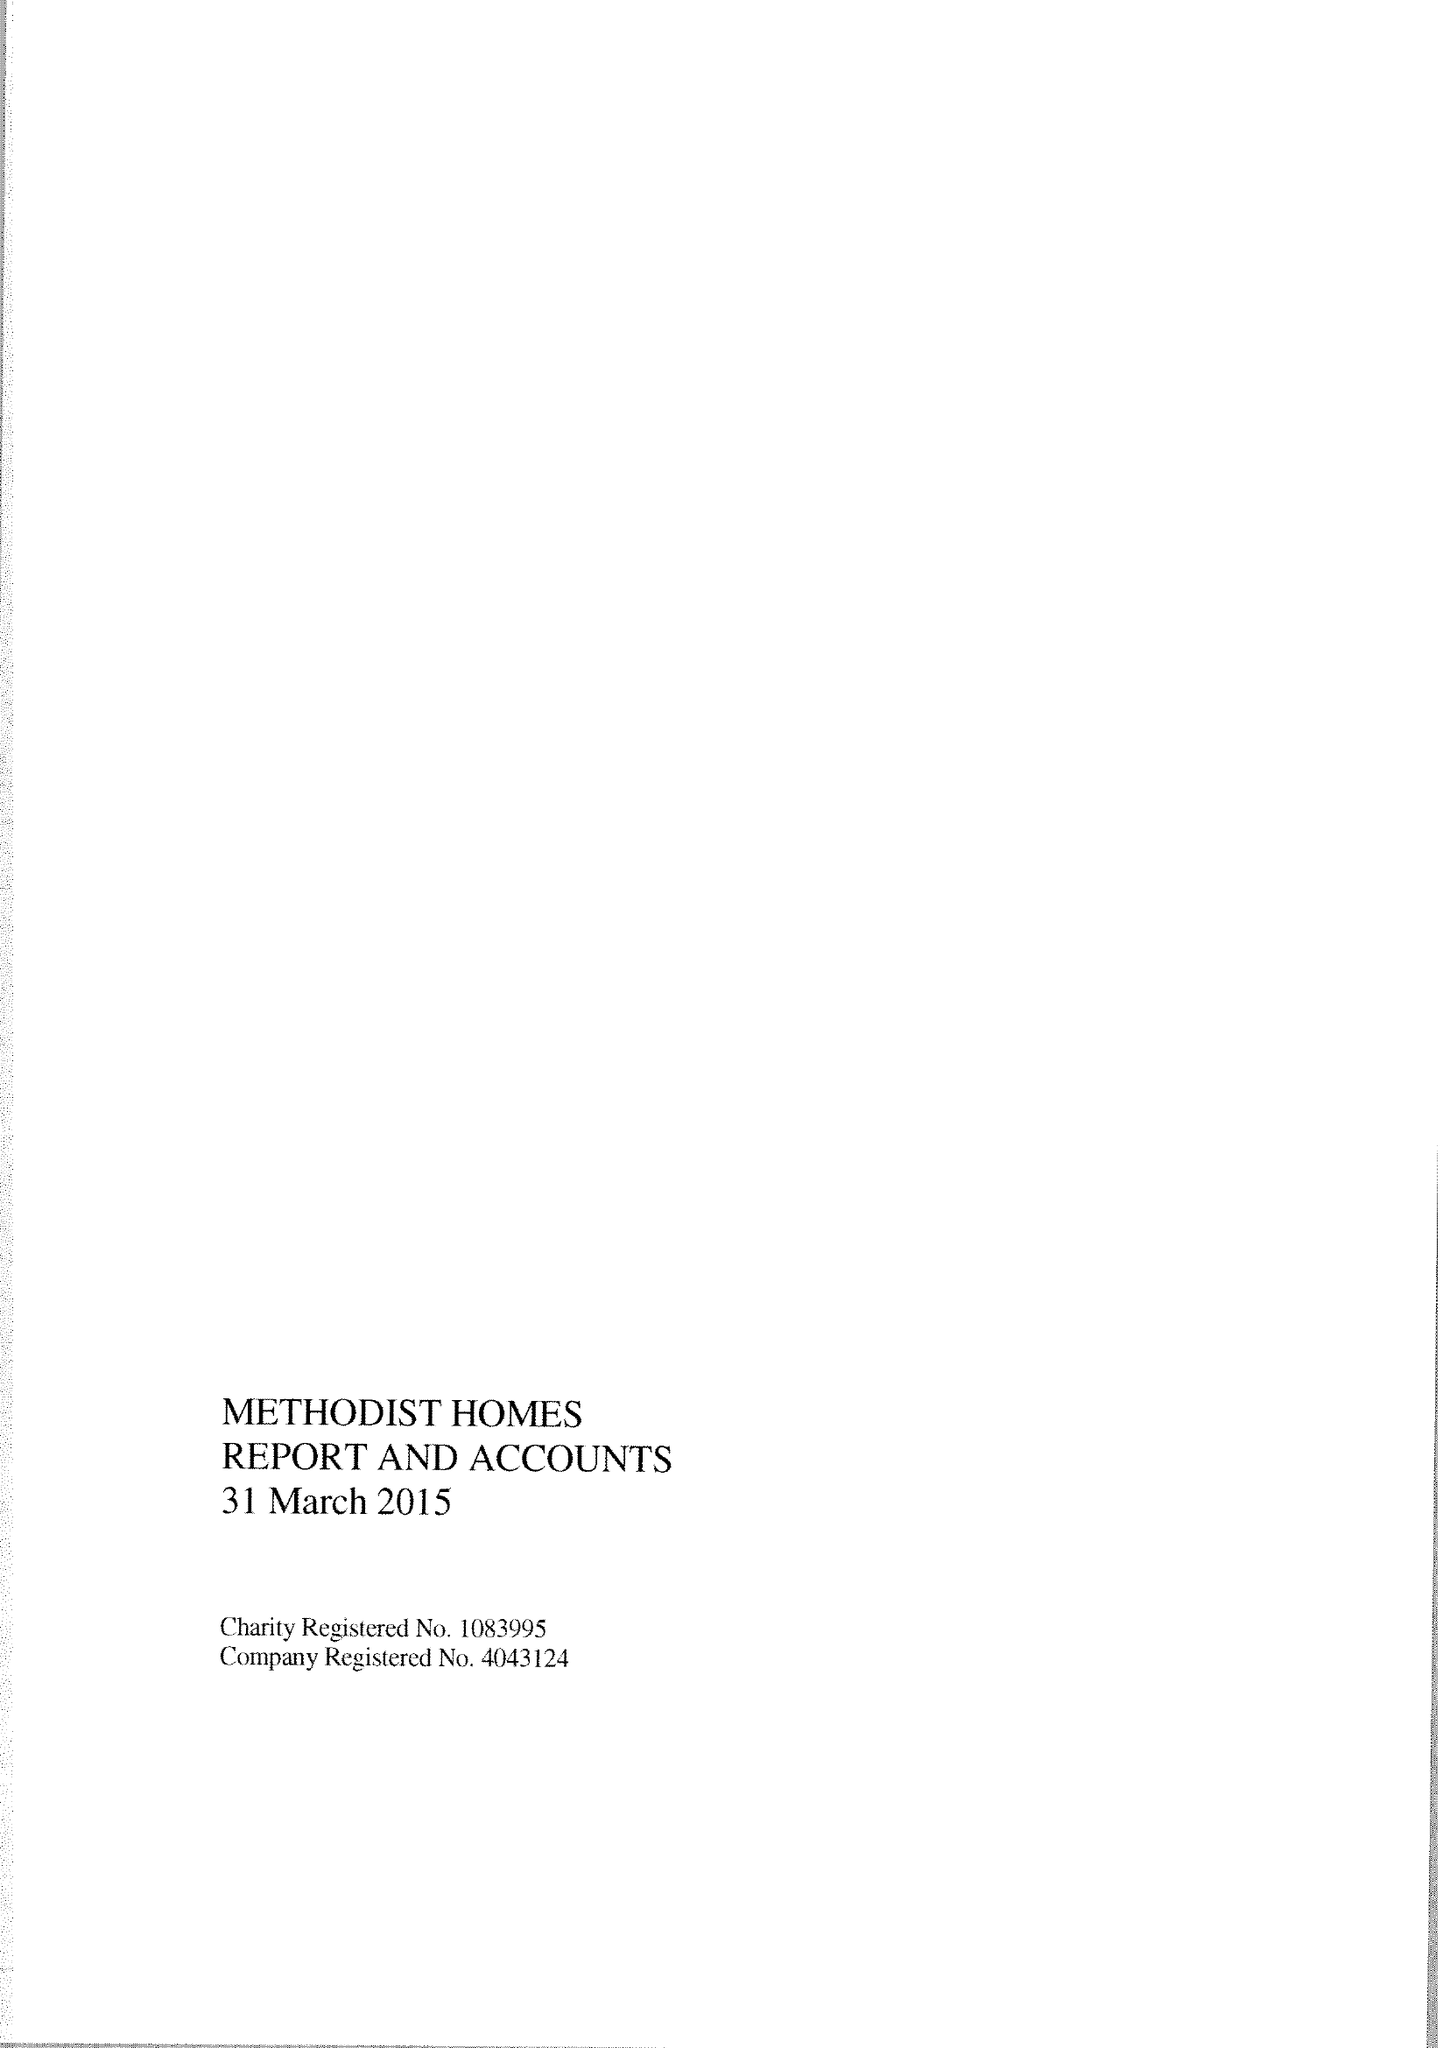What is the value for the income_annually_in_british_pounds?
Answer the question using a single word or phrase. 179826000.00 